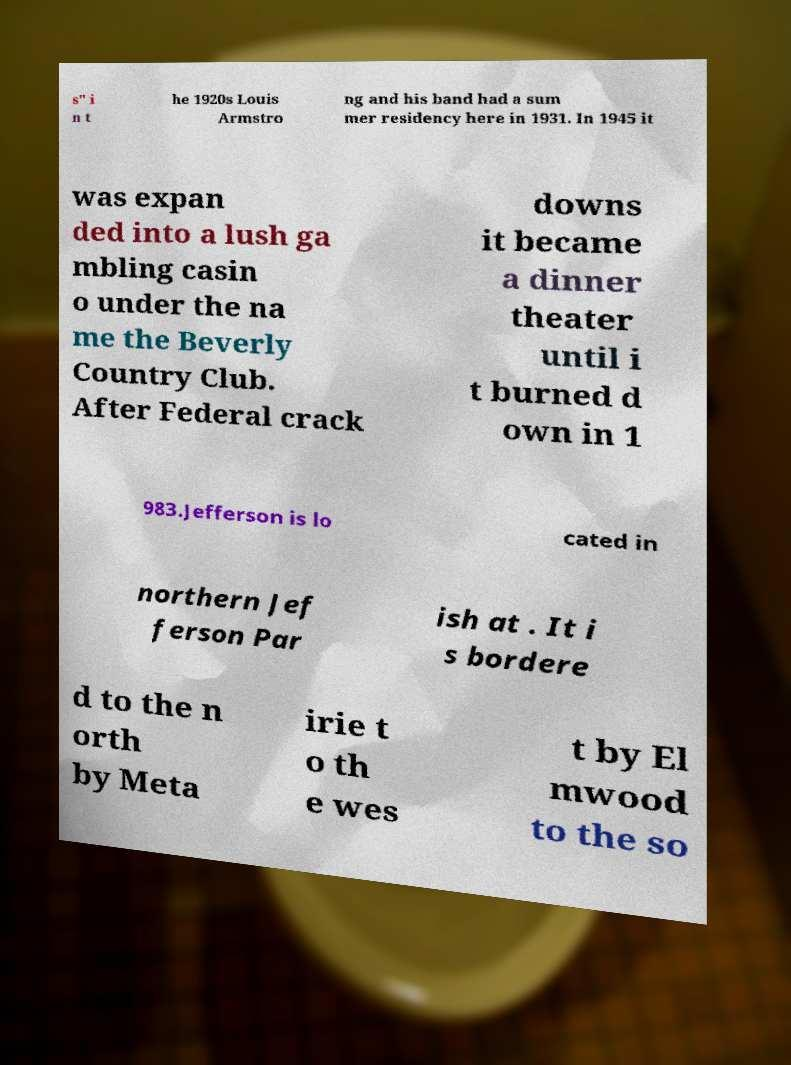For documentation purposes, I need the text within this image transcribed. Could you provide that? s" i n t he 1920s Louis Armstro ng and his band had a sum mer residency here in 1931. In 1945 it was expan ded into a lush ga mbling casin o under the na me the Beverly Country Club. After Federal crack downs it became a dinner theater until i t burned d own in 1 983.Jefferson is lo cated in northern Jef ferson Par ish at . It i s bordere d to the n orth by Meta irie t o th e wes t by El mwood to the so 